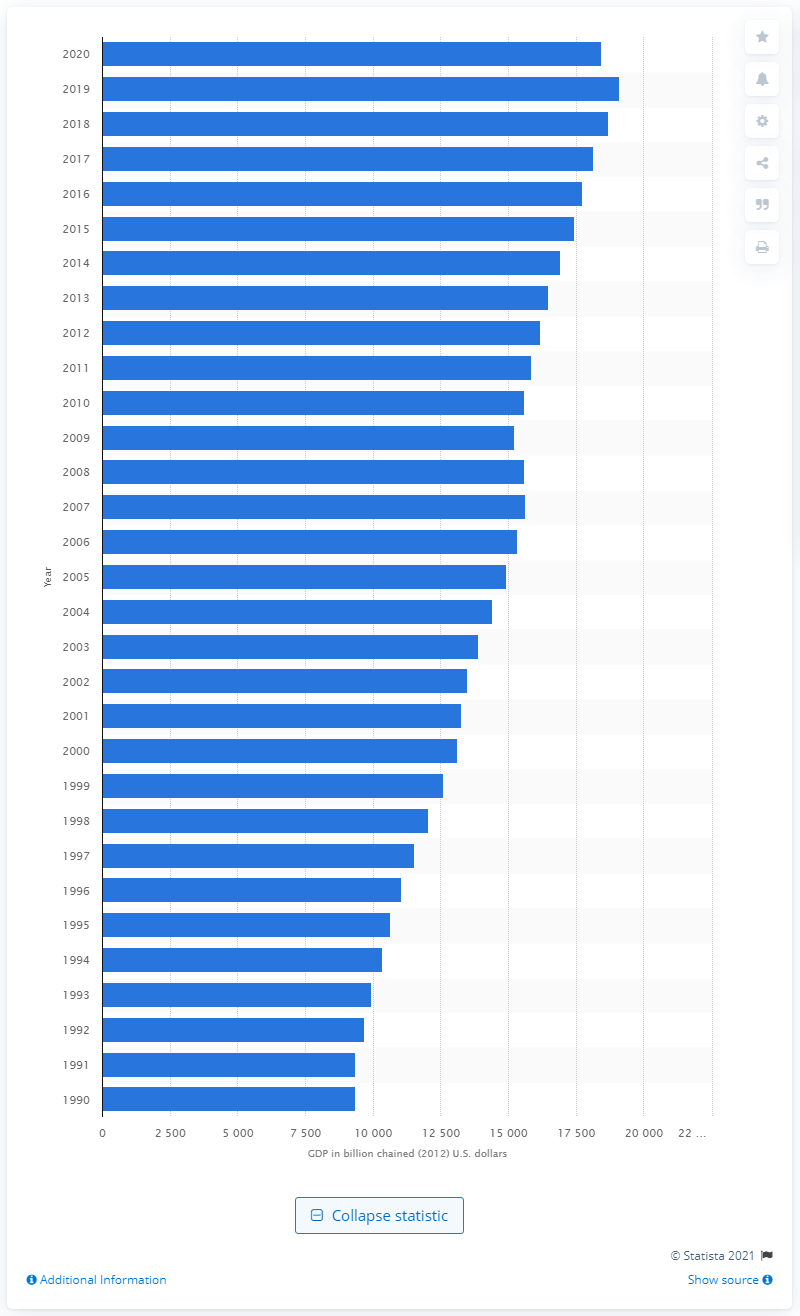Mention a couple of crucial points in this snapshot. The United States generated 18,422.6 million U.S. dollars in 2020. 